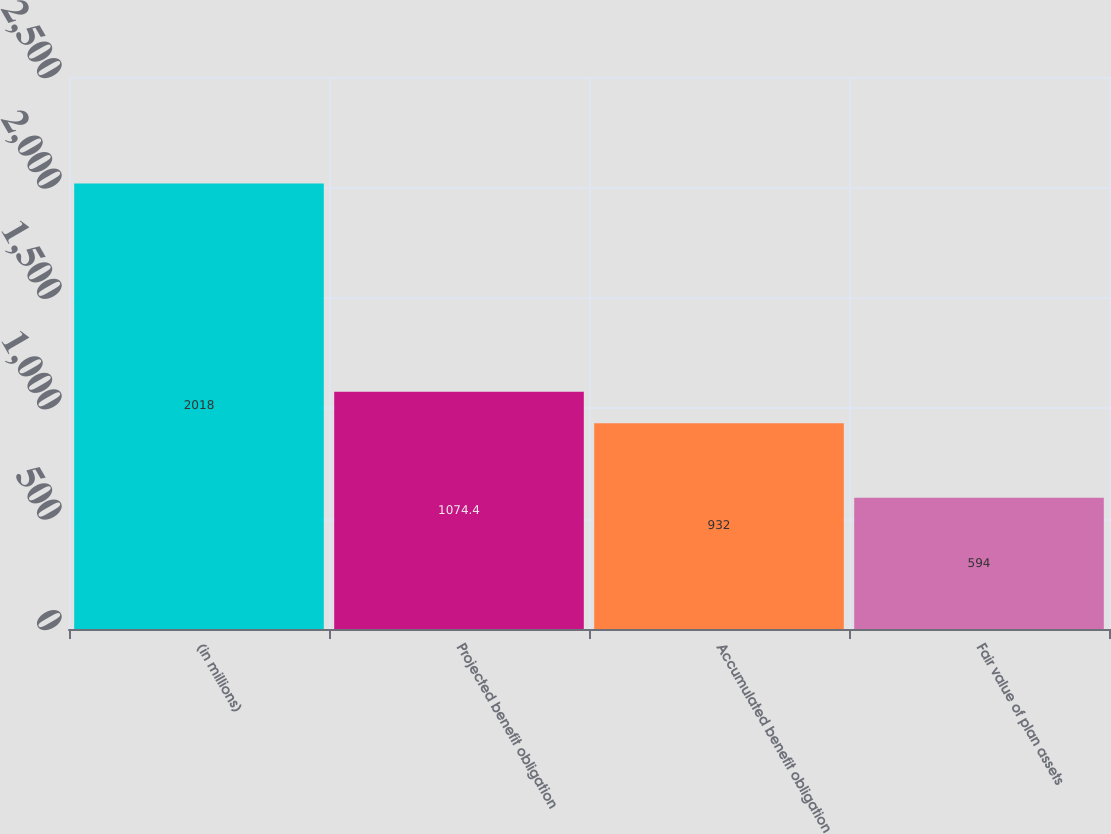<chart> <loc_0><loc_0><loc_500><loc_500><bar_chart><fcel>(in millions)<fcel>Projected benefit obligation<fcel>Accumulated benefit obligation<fcel>Fair value of plan assets<nl><fcel>2018<fcel>1074.4<fcel>932<fcel>594<nl></chart> 